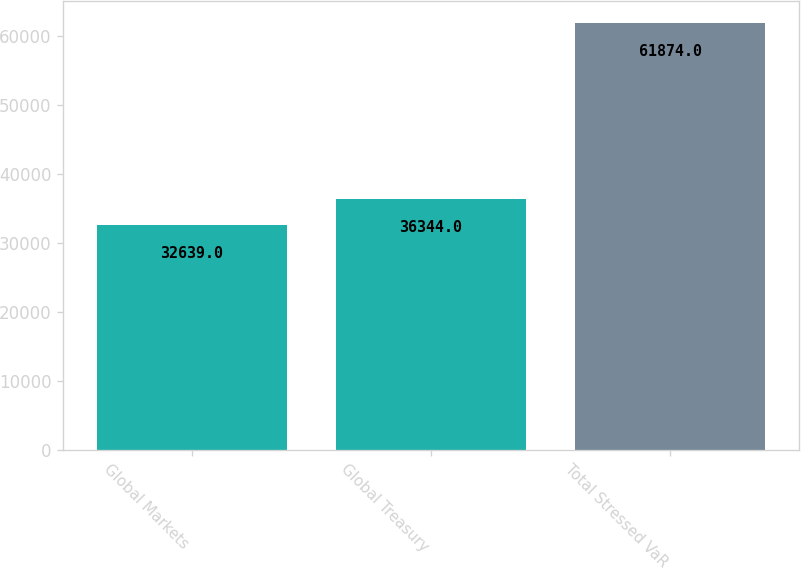Convert chart. <chart><loc_0><loc_0><loc_500><loc_500><bar_chart><fcel>Global Markets<fcel>Global Treasury<fcel>Total Stressed VaR<nl><fcel>32639<fcel>36344<fcel>61874<nl></chart> 